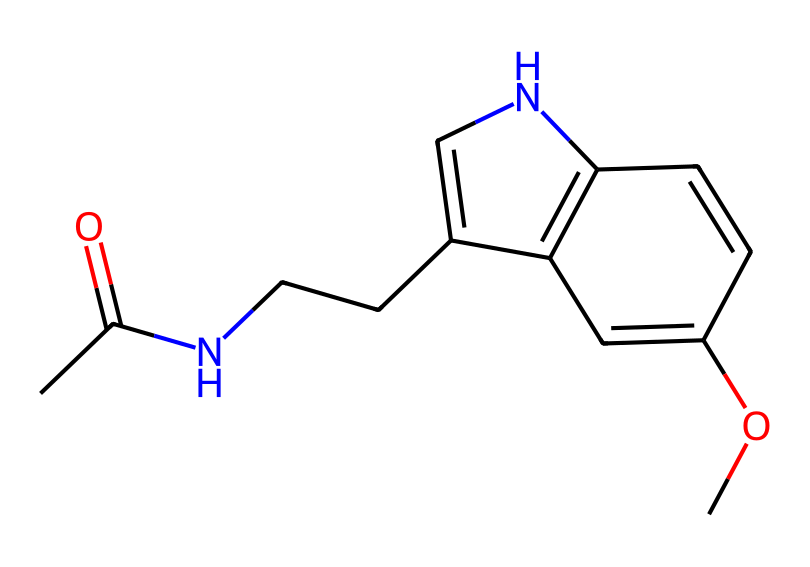What is the molecular formula of melatonin? By analyzing the SMILES representation, the constituent atoms can be counted: there are 13 carbon atoms, 16 hydrogen atoms, 2 nitrogen atoms, and 2 oxygen atoms. Thus, the molecular formula is C13H16N2O2.
Answer: C13H16N2O2 How many rings are present in the structure of melatonin? The SMILES indicates the presence of two distinct rings in the molecular structure; the cyclic components can be identified by the numerical indicators denoting ring closures.
Answer: 2 What functional groups are present in melatonin? Upon examining the structure, there are key functional groups: an amide group (from the -N-C=O), and a methoxy group (-O-CH3). The presence of these groups can be inferred from the arrangement of atoms in the SMILES.
Answer: amide and methoxy What does the presence of nitrogen atoms suggest about melatonin's properties? Nitrogen atoms typically suggest the potential for interactions like hydrogen bonding, which can affect the solubility and reactivity of the compound in biological systems, including its role in sleep regulation.
Answer: hydrogen bonding potential How might the structure of melatonin affect sleep patterns in characters? The specific arrangement and presence of functional groups (like the methoxy and amide groups) in melatonin allow it to interact with receptors in the brain that regulate sleep, influencing its sedative properties. This structure ultimately supports the function of melatonin as a regulator of circadian rhythms and sleep cycles.
Answer: regulates sleep patterns What implications does melatonin's structural complexity have on mood regulation? Melatonin's complexity, including its two nitrogen atoms and multiple functional groups, contributes to its ability to influence various neurotransmitters in the brain, which can significantly affect mood and emotional states. This interaction with neurotransmitter systems helps to explain mood regulation.
Answer: influences mood regulation 